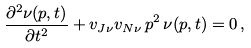Convert formula to latex. <formula><loc_0><loc_0><loc_500><loc_500>\frac { \partial ^ { 2 } \nu ( p , t ) } { \partial t ^ { 2 } } + v _ { J \nu } v _ { N \nu } \, p ^ { 2 } \, \nu ( p , t ) = 0 \, ,</formula> 